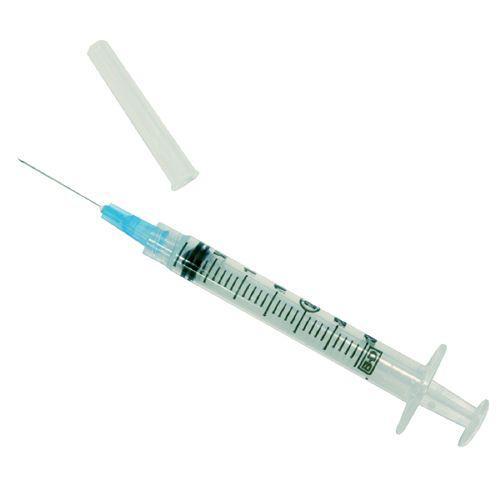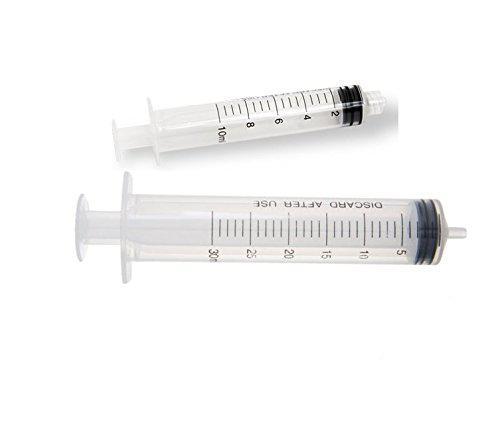The first image is the image on the left, the second image is the image on the right. Analyze the images presented: Is the assertion "There is exactly one syringe in the left image." valid? Answer yes or no. Yes. The first image is the image on the left, the second image is the image on the right. Assess this claim about the two images: "There are 3 or fewer syringes total.". Correct or not? Answer yes or no. Yes. 